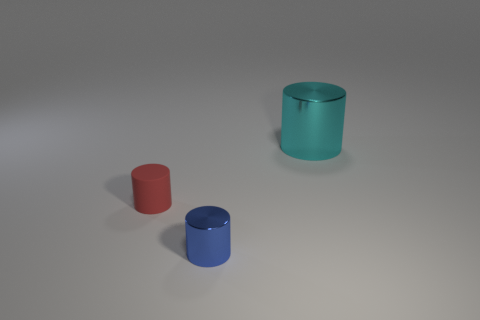There is another large object that is the same shape as the blue metal object; what is it made of?
Offer a terse response. Metal. What shape is the other blue thing that is made of the same material as the big object?
Offer a terse response. Cylinder. There is a metallic cylinder that is in front of the red object; is its size the same as the cylinder behind the rubber cylinder?
Provide a succinct answer. No. What is the color of the large thing?
Your answer should be compact. Cyan. Do the red rubber cylinder and the metallic cylinder that is to the left of the large shiny cylinder have the same size?
Keep it short and to the point. Yes. What number of metallic things are cylinders or small red cubes?
Provide a short and direct response. 2. Is there anything else that is the same material as the tiny red cylinder?
Ensure brevity in your answer.  No. There is a metallic thing in front of the tiny object that is left of the cylinder that is in front of the tiny rubber object; what size is it?
Your answer should be very brief. Small. How many other things are there of the same shape as the cyan shiny thing?
Ensure brevity in your answer.  2. Do the small red object to the left of the small blue metallic object and the metallic thing that is in front of the big metal cylinder have the same shape?
Your response must be concise. Yes. 